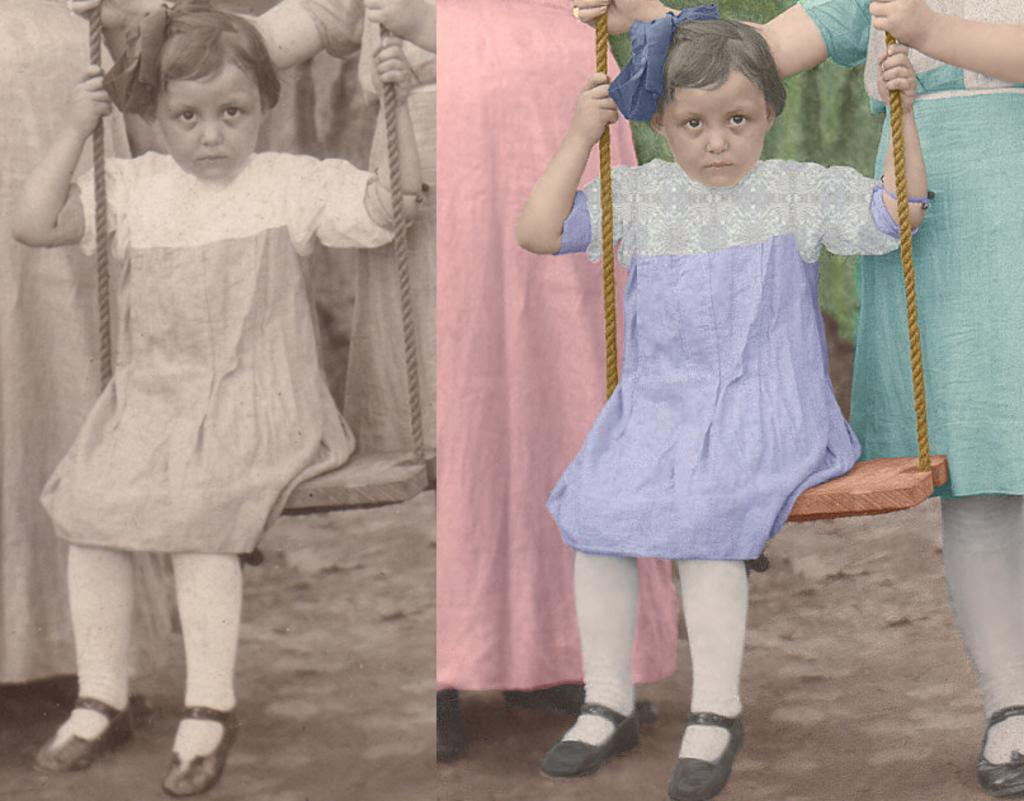What is the position of the girl in the image? The girl is sitting in the front of the image. Can you describe the people in the background of the image? There are persons standing in the background of the image. What type of badge is the girl wearing in the image? There is no badge visible on the girl in the image. Can you see any cows or bats in the image? No, there are no cows or bats present in the image. 